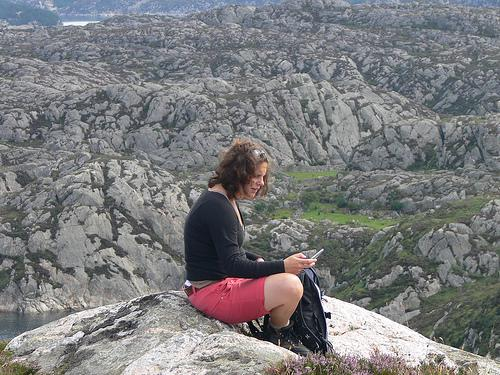Question: where is this taken?
Choices:
A. On a mountain.
B. In the woods.
C. On the beach.
D. National park.
Answer with the letter. Answer: A Question: what color are the rock formations?
Choices:
A. Brown.
B. Red.
C. Yellow.
D. Grey.
Answer with the letter. Answer: D Question: what is she doing with her hands?
Choices:
A. Washing dishes.
B. Brushing her hair.
C. Taking a picture.
D. On a phone.
Answer with the letter. Answer: D Question: how did she get up there?
Choices:
A. Jump.
B. Climb or walk.
C. Used a rope.
D. Got pulled.
Answer with the letter. Answer: B Question: what gender is the person in the picture?
Choices:
A. Female.
B. Male.
C. Feminine.
D. Masculine.
Answer with the letter. Answer: A Question: what is in the bottom right hand corner?
Choices:
A. Bushes.
B. Flowers.
C. Trees.
D. Grass.
Answer with the letter. Answer: B Question: what color is her shirt?
Choices:
A. White.
B. Black.
C. Blue.
D. Red.
Answer with the letter. Answer: B 